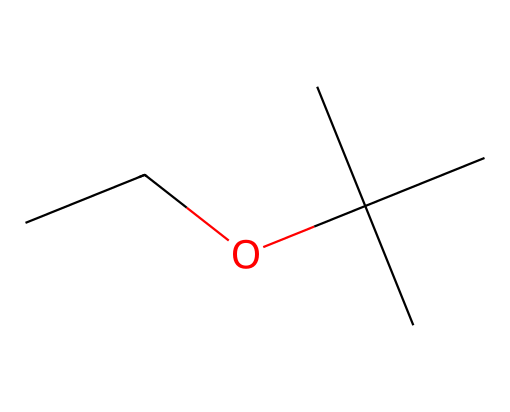What is the name of this compound? The SMILES representation indicates the structure is ethyl tert-butyl ether. The 'CC' at the beginning signifies an ethyl group, while 'C(C)(C)' denotes a tert-butyl group. Combining these provides the name.
Answer: ethyl tert-butyl ether How many carbon atoms are present in this compound? The SMILES notation breaks down to two carbon atoms in the ethyl group and four carbon atoms in the tert-butyl group, summing to a total of six carbon atoms.
Answer: six What is the number of oxygen atoms in this structure? The SMILES structure has 'O' indicating the presence of one oxygen atom, which is typical for an ether linkage in the molecule.
Answer: one What type of chemical bonding is predominant in this ether? The structure indicates that single bonds primarily connect all carbon atoms and between carbon and oxygen, typical for ethers. Multiple bonds or alternate bonding is not present here.
Answer: single bonds What is the functional group present in ethyl tert-butyl ether? The 'O' in the SMILES represents the ether functional group, which is identified by the presence of an oxygen atom connected to two alkyl groups (ethyl and tert-butyl).
Answer: ether What characteristic gives this compound octane-boosting properties? The branched structure of the tert-butyl group allows for improved combustion efficiency, enhancing the octane rating in gasoline, compared to straight-chain counterparts.
Answer: branched structure 